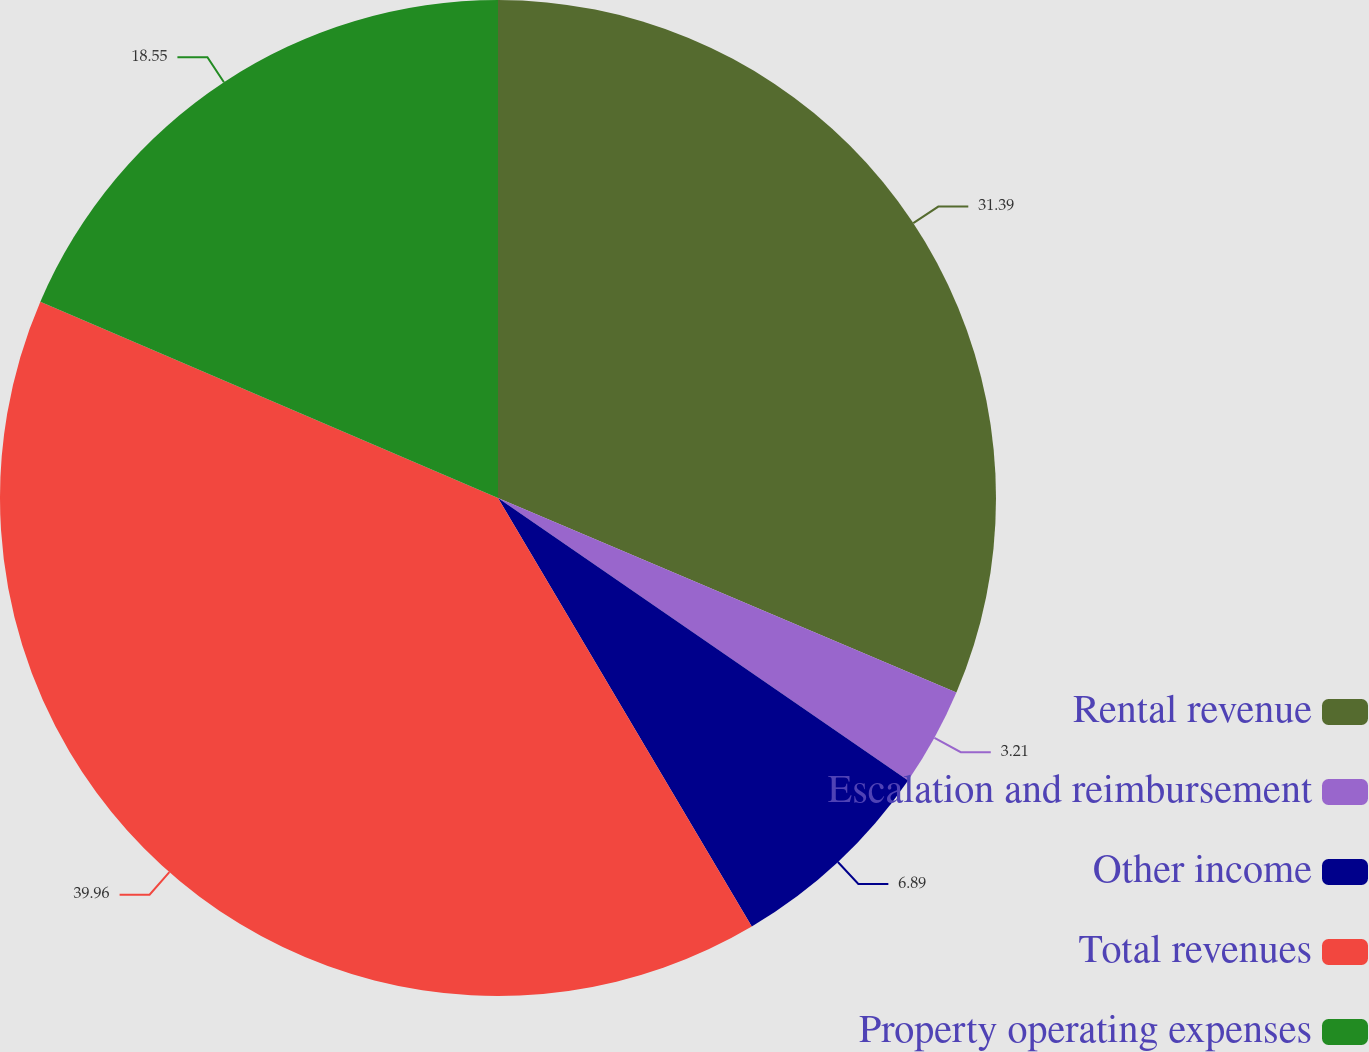Convert chart. <chart><loc_0><loc_0><loc_500><loc_500><pie_chart><fcel>Rental revenue<fcel>Escalation and reimbursement<fcel>Other income<fcel>Total revenues<fcel>Property operating expenses<nl><fcel>31.39%<fcel>3.21%<fcel>6.89%<fcel>39.96%<fcel>18.55%<nl></chart> 